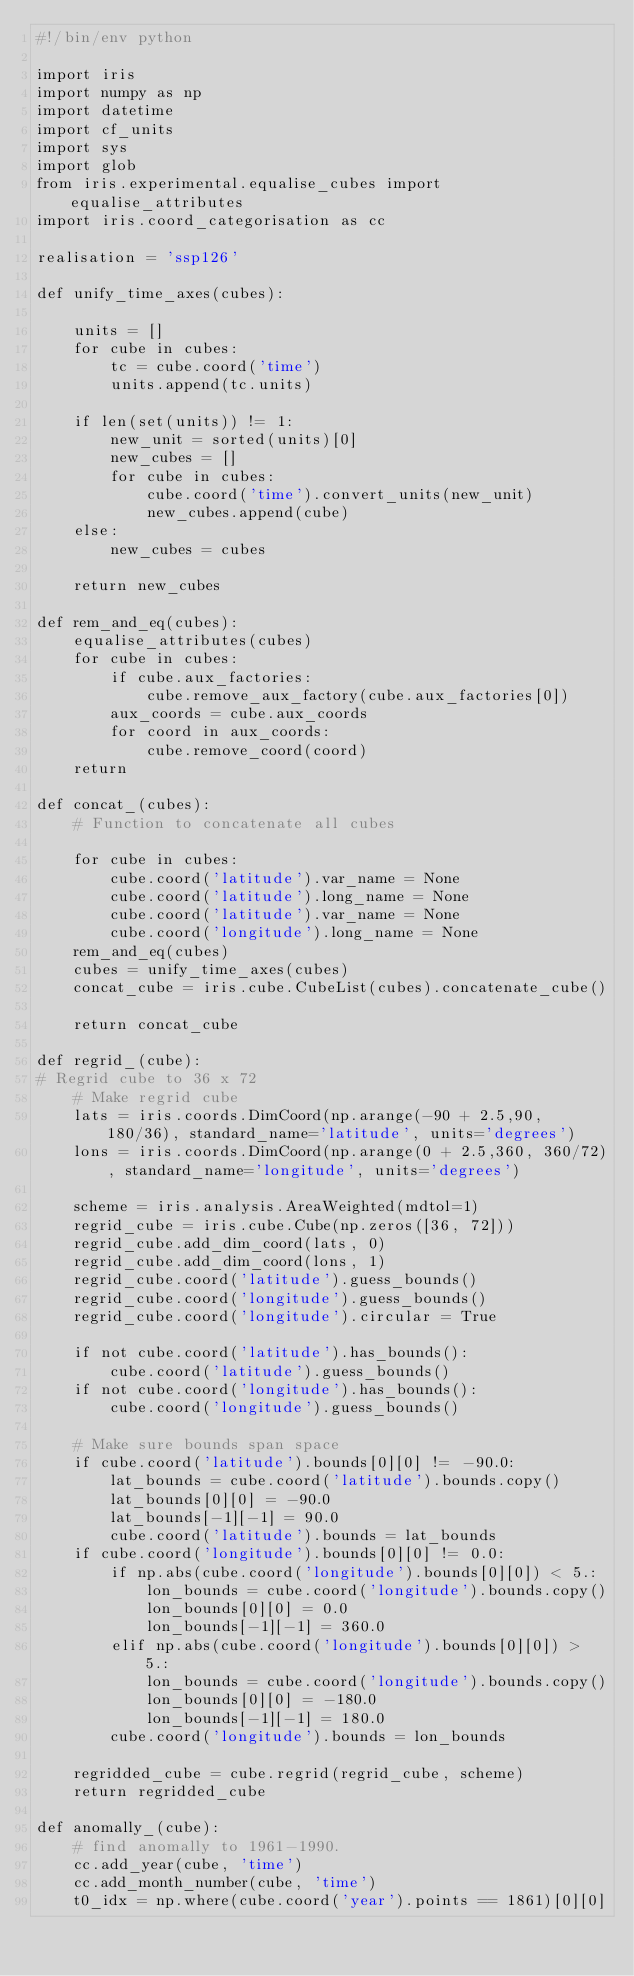<code> <loc_0><loc_0><loc_500><loc_500><_Python_>#!/bin/env python

import iris
import numpy as np
import datetime
import cf_units
import sys
import glob
from iris.experimental.equalise_cubes import equalise_attributes
import iris.coord_categorisation as cc

realisation = 'ssp126'

def unify_time_axes(cubes):

    units = []
    for cube in cubes:
        tc = cube.coord('time')
        units.append(tc.units)

    if len(set(units)) != 1:
        new_unit = sorted(units)[0]
        new_cubes = []
        for cube in cubes:
            cube.coord('time').convert_units(new_unit)
            new_cubes.append(cube)
    else:
        new_cubes = cubes

    return new_cubes

def rem_and_eq(cubes):
    equalise_attributes(cubes)
    for cube in cubes:
        if cube.aux_factories:
            cube.remove_aux_factory(cube.aux_factories[0])
        aux_coords = cube.aux_coords
        for coord in aux_coords:
            cube.remove_coord(coord)
    return

def concat_(cubes):
    # Function to concatenate all cubes

    for cube in cubes:
        cube.coord('latitude').var_name = None
        cube.coord('latitude').long_name = None
        cube.coord('latitude').var_name = None
        cube.coord('longitude').long_name = None
    rem_and_eq(cubes)
    cubes = unify_time_axes(cubes)
    concat_cube = iris.cube.CubeList(cubes).concatenate_cube()

    return concat_cube

def regrid_(cube):
# Regrid cube to 36 x 72
    # Make regrid cube
    lats = iris.coords.DimCoord(np.arange(-90 + 2.5,90, 180/36), standard_name='latitude', units='degrees')
    lons = iris.coords.DimCoord(np.arange(0 + 2.5,360, 360/72), standard_name='longitude', units='degrees')

    scheme = iris.analysis.AreaWeighted(mdtol=1)
    regrid_cube = iris.cube.Cube(np.zeros([36, 72]))
    regrid_cube.add_dim_coord(lats, 0)
    regrid_cube.add_dim_coord(lons, 1)
    regrid_cube.coord('latitude').guess_bounds()
    regrid_cube.coord('longitude').guess_bounds()
    regrid_cube.coord('longitude').circular = True

    if not cube.coord('latitude').has_bounds():
        cube.coord('latitude').guess_bounds()
    if not cube.coord('longitude').has_bounds():
        cube.coord('longitude').guess_bounds()

    # Make sure bounds span space
    if cube.coord('latitude').bounds[0][0] != -90.0:
        lat_bounds = cube.coord('latitude').bounds.copy()
        lat_bounds[0][0] = -90.0
        lat_bounds[-1][-1] = 90.0
        cube.coord('latitude').bounds = lat_bounds
    if cube.coord('longitude').bounds[0][0] != 0.0:
        if np.abs(cube.coord('longitude').bounds[0][0]) < 5.:
            lon_bounds = cube.coord('longitude').bounds.copy()
            lon_bounds[0][0] = 0.0
            lon_bounds[-1][-1] = 360.0
        elif np.abs(cube.coord('longitude').bounds[0][0]) > 5.:
            lon_bounds = cube.coord('longitude').bounds.copy()
            lon_bounds[0][0] = -180.0
            lon_bounds[-1][-1] = 180.0
        cube.coord('longitude').bounds = lon_bounds

    regridded_cube = cube.regrid(regrid_cube, scheme)
    return regridded_cube

def anomally_(cube):
    # find anomally to 1961-1990.
    cc.add_year(cube, 'time')
    cc.add_month_number(cube, 'time')
    t0_idx = np.where(cube.coord('year').points == 1861)[0][0]</code> 